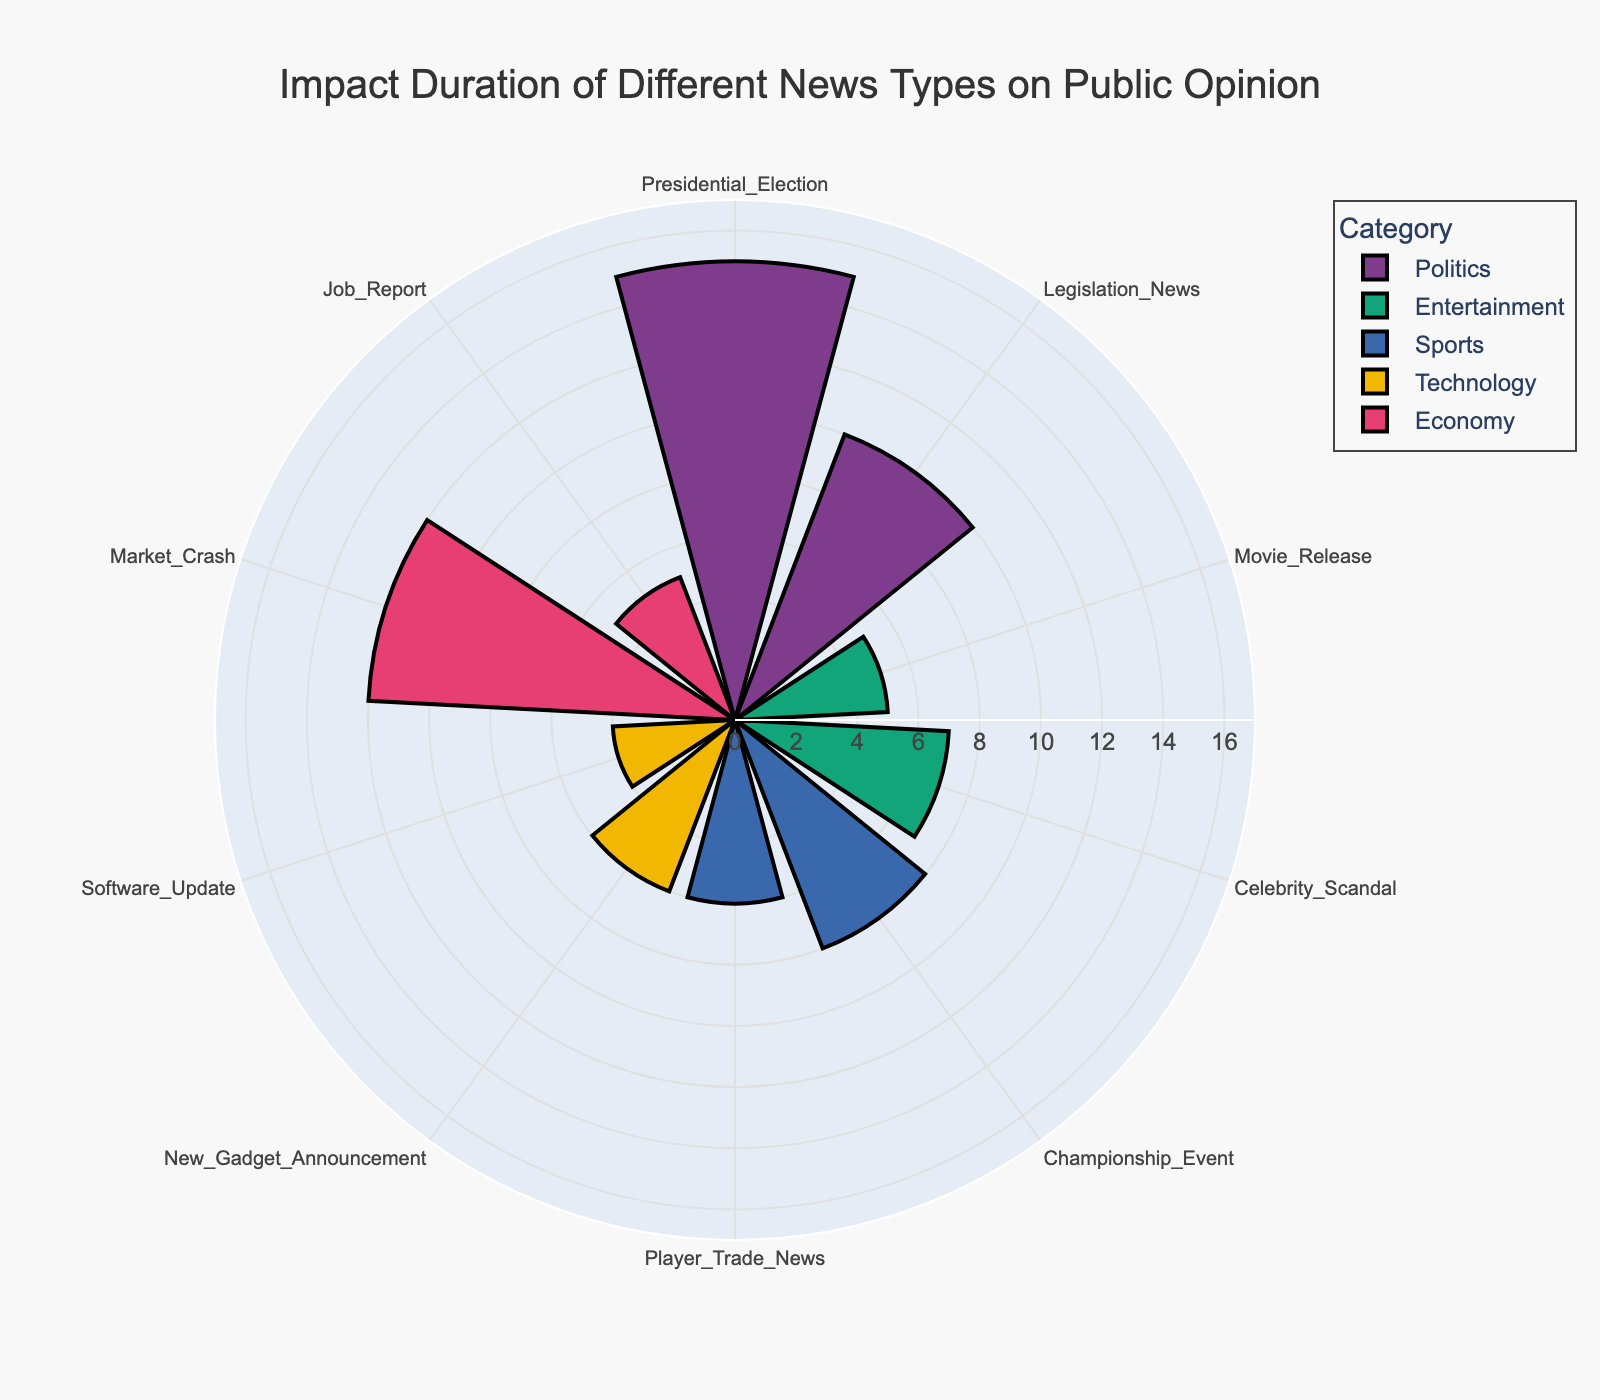What's the title of the figure? The title of the figure is typically positioned at the top and often in a larger font size to stand out.
Answer: Impact Duration of Different News Types on Public Opinion How many news types are shown in the figure? Identify all unique news types displayed around the polar chart.
Answer: 10 Which news type has the shortest impact duration on public opinion? Identify the segment with the smallest radial axis length.
Answer: Software Update Which news category has the highest impact duration day? Look for the bar with the longest radial axis and note its category.
Answer: Politics What's the difference in impact duration between a Championship Event and a Market Crash? Find the radial lengths corresponding to the Championship Event and Market Crash, then subtract the smaller value from the larger one.
Answer: 4 days Is the impact duration of Movie Release longer than that of Player Trade News? Compare the radial lengths (r values) of Movie Release and Player Trade News.
Answer: No Which category has a more uniform impact duration between its news types: Entertainment or Technology? Compare the variation in the lengths of the bars under each category.
Answer: Technology What is the combined impact duration of all news types in the Entertainment category? Sum the radial lengths corresponding to Movie Release and Celebrity Scandal.
Answer: 12 days What’s the average impact duration of the impact categories presented in the figure? Sum the radial values of all news types and divide by the number of news types (10).
Answer: 78/10 = 7.8 days In which direction (clockwise or counterclockwise) is the angular axis? Determine the direction of the ticks around the polar chart.
Answer: Clockwise 